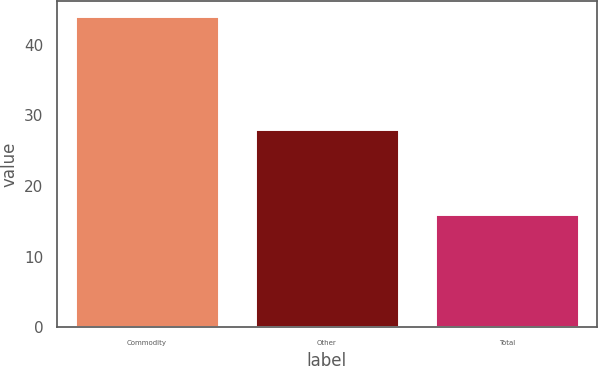Convert chart. <chart><loc_0><loc_0><loc_500><loc_500><bar_chart><fcel>Commodity<fcel>Other<fcel>Total<nl><fcel>44<fcel>28<fcel>16<nl></chart> 